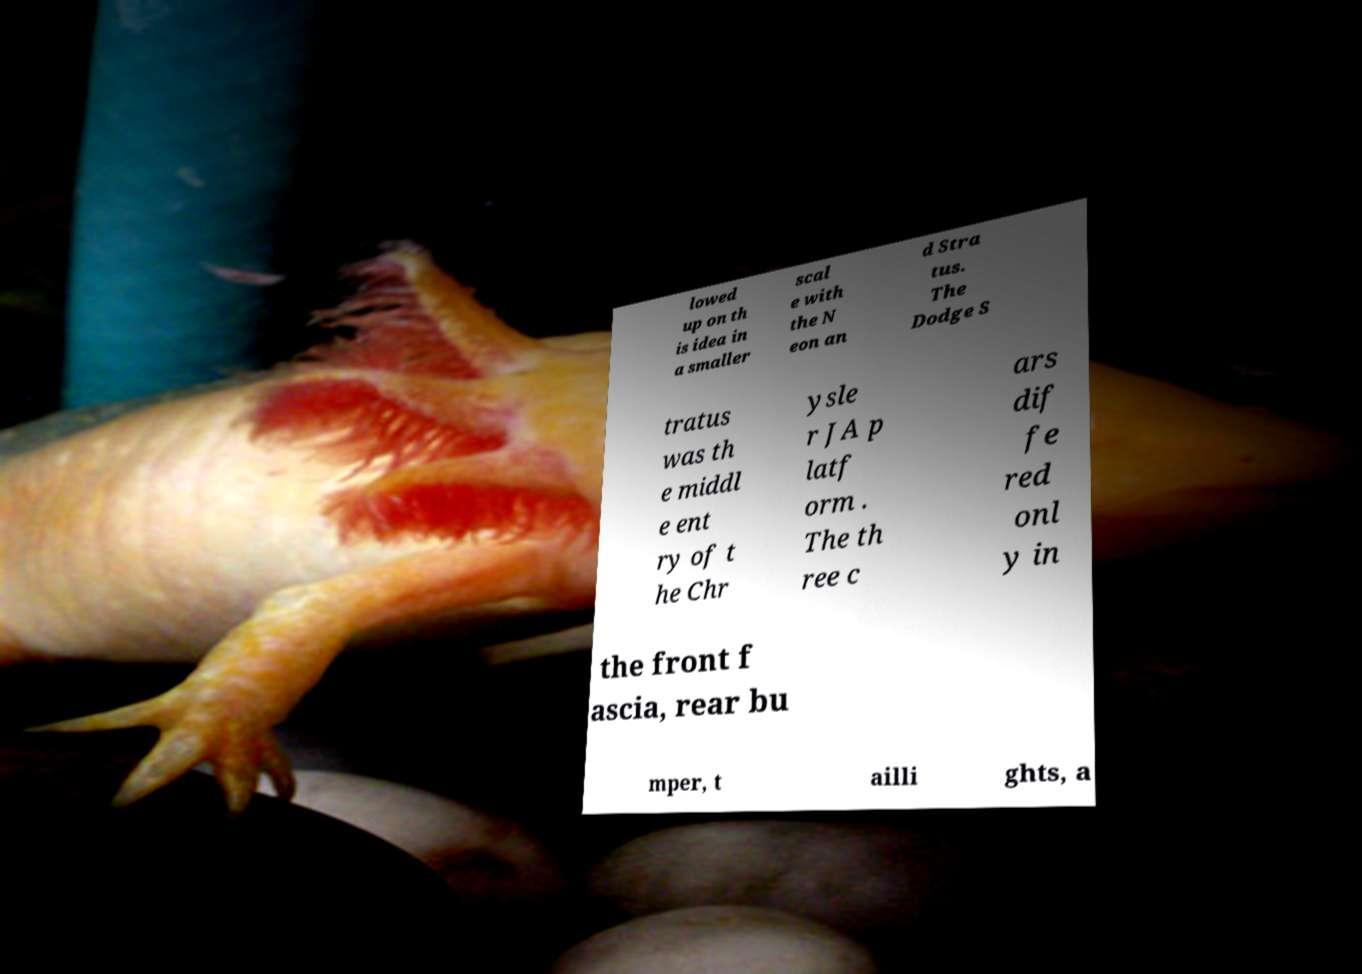Can you accurately transcribe the text from the provided image for me? lowed up on th is idea in a smaller scal e with the N eon an d Stra tus. The Dodge S tratus was th e middl e ent ry of t he Chr ysle r JA p latf orm . The th ree c ars dif fe red onl y in the front f ascia, rear bu mper, t ailli ghts, a 